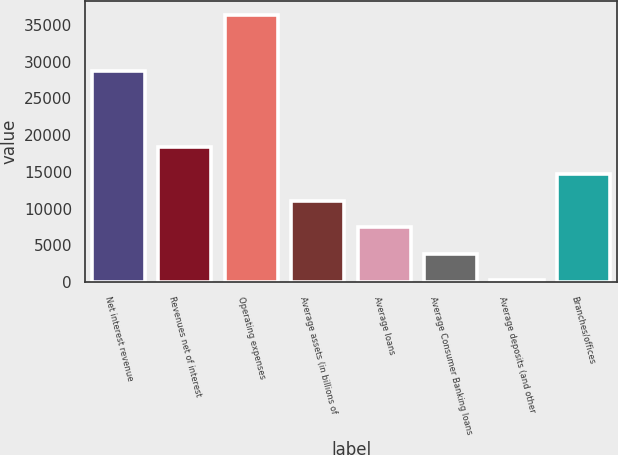<chart> <loc_0><loc_0><loc_500><loc_500><bar_chart><fcel>Net interest revenue<fcel>Revenues net of interest<fcel>Operating expenses<fcel>Average assets (in billions of<fcel>Average loans<fcel>Average Consumer Banking loans<fcel>Average deposits (and other<fcel>Branches/offices<nl><fcel>28713<fcel>18334.3<fcel>36407<fcel>11105.2<fcel>7490.68<fcel>3876.14<fcel>261.6<fcel>14719.8<nl></chart> 